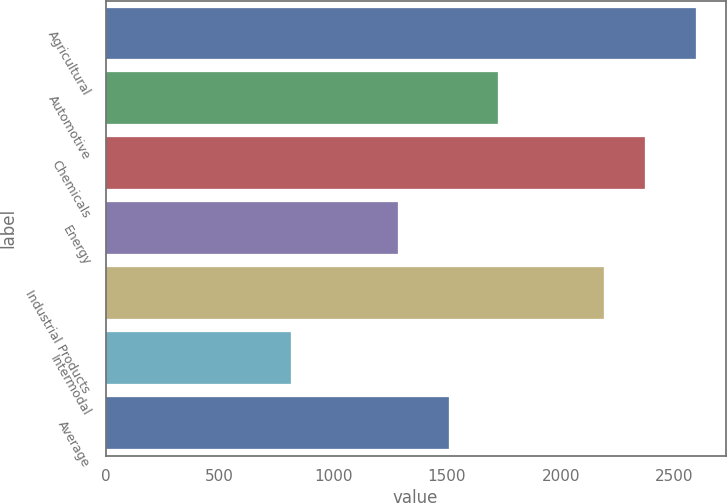Convert chart. <chart><loc_0><loc_0><loc_500><loc_500><bar_chart><fcel>Agricultural<fcel>Automotive<fcel>Chemicals<fcel>Energy<fcel>Industrial Products<fcel>Intermodal<fcel>Average<nl><fcel>2595<fcel>1724<fcel>2368.2<fcel>1286<fcel>2190<fcel>813<fcel>1509<nl></chart> 